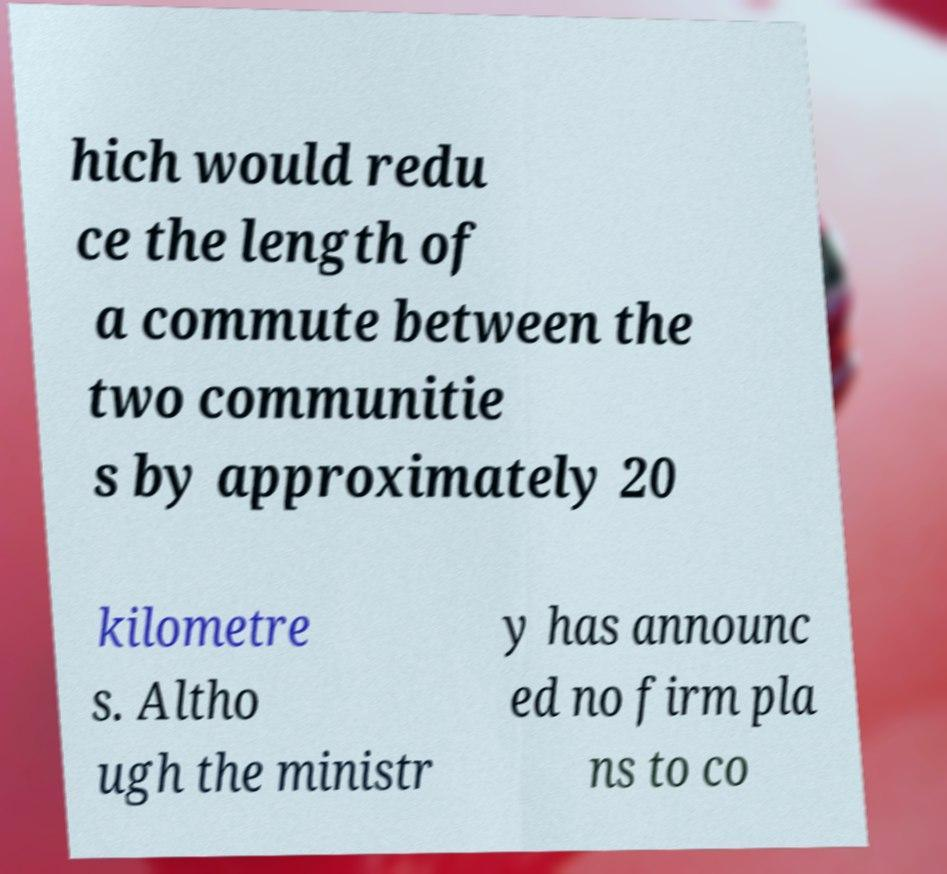There's text embedded in this image that I need extracted. Can you transcribe it verbatim? hich would redu ce the length of a commute between the two communitie s by approximately 20 kilometre s. Altho ugh the ministr y has announc ed no firm pla ns to co 